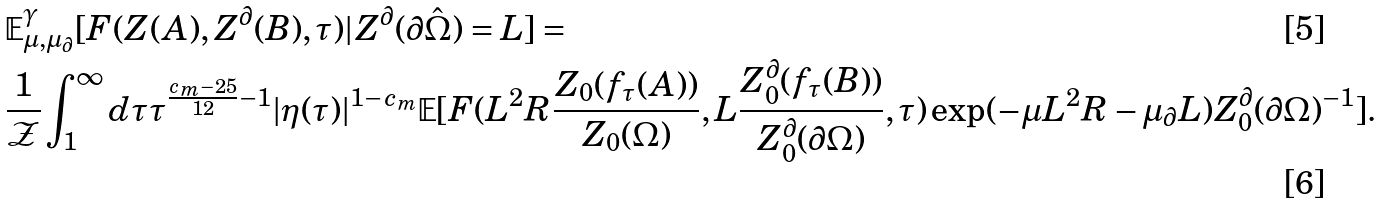Convert formula to latex. <formula><loc_0><loc_0><loc_500><loc_500>& \mathbb { E } ^ { \gamma } _ { \mu , \mu _ { \partial } } [ F ( Z ( A ) , Z ^ { \partial } ( B ) , \tau ) | Z ^ { \partial } ( \partial \hat { \Omega } ) = L ] = \\ & \frac { 1 } { \mathcal { Z } } \int _ { 1 } ^ { \infty } d \tau \tau ^ { \frac { c _ { m } - 2 5 } { 1 2 } - 1 } | \eta ( \tau ) | ^ { 1 - c _ { m } } \mathbb { E } [ F ( L ^ { 2 } R \frac { Z _ { 0 } ( f _ { \tau } ( A ) ) } { Z _ { 0 } ( \Omega ) } , L \frac { Z _ { 0 } ^ { \partial } ( f _ { \tau } ( B ) ) } { Z _ { 0 } ^ { \partial } ( \partial \Omega ) } , \tau ) \exp ( - \mu L ^ { 2 } R - \mu _ { \partial } L ) Z _ { 0 } ^ { \partial } ( \partial \Omega ) ^ { - 1 } ] .</formula> 